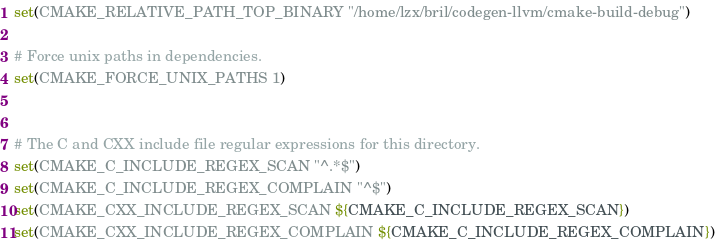<code> <loc_0><loc_0><loc_500><loc_500><_CMake_>set(CMAKE_RELATIVE_PATH_TOP_BINARY "/home/lzx/bril/codegen-llvm/cmake-build-debug")

# Force unix paths in dependencies.
set(CMAKE_FORCE_UNIX_PATHS 1)


# The C and CXX include file regular expressions for this directory.
set(CMAKE_C_INCLUDE_REGEX_SCAN "^.*$")
set(CMAKE_C_INCLUDE_REGEX_COMPLAIN "^$")
set(CMAKE_CXX_INCLUDE_REGEX_SCAN ${CMAKE_C_INCLUDE_REGEX_SCAN})
set(CMAKE_CXX_INCLUDE_REGEX_COMPLAIN ${CMAKE_C_INCLUDE_REGEX_COMPLAIN})
</code> 